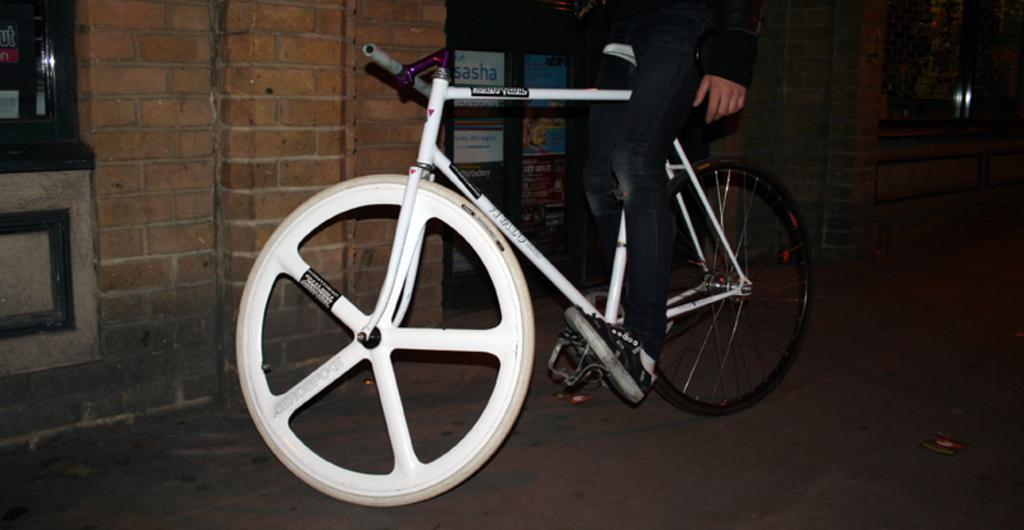What is the person in the image doing? The person is sitting on a bicycle in the image. What is located beside the person? There is a door beside the person. What can be seen on the wall in the image? There is a window and posters on the wall. What type of yam is being used as a shoe in the image? There is no yam or shoe present in the image; it features a person sitting on a bicycle with a door, window, and posters on the wall. 